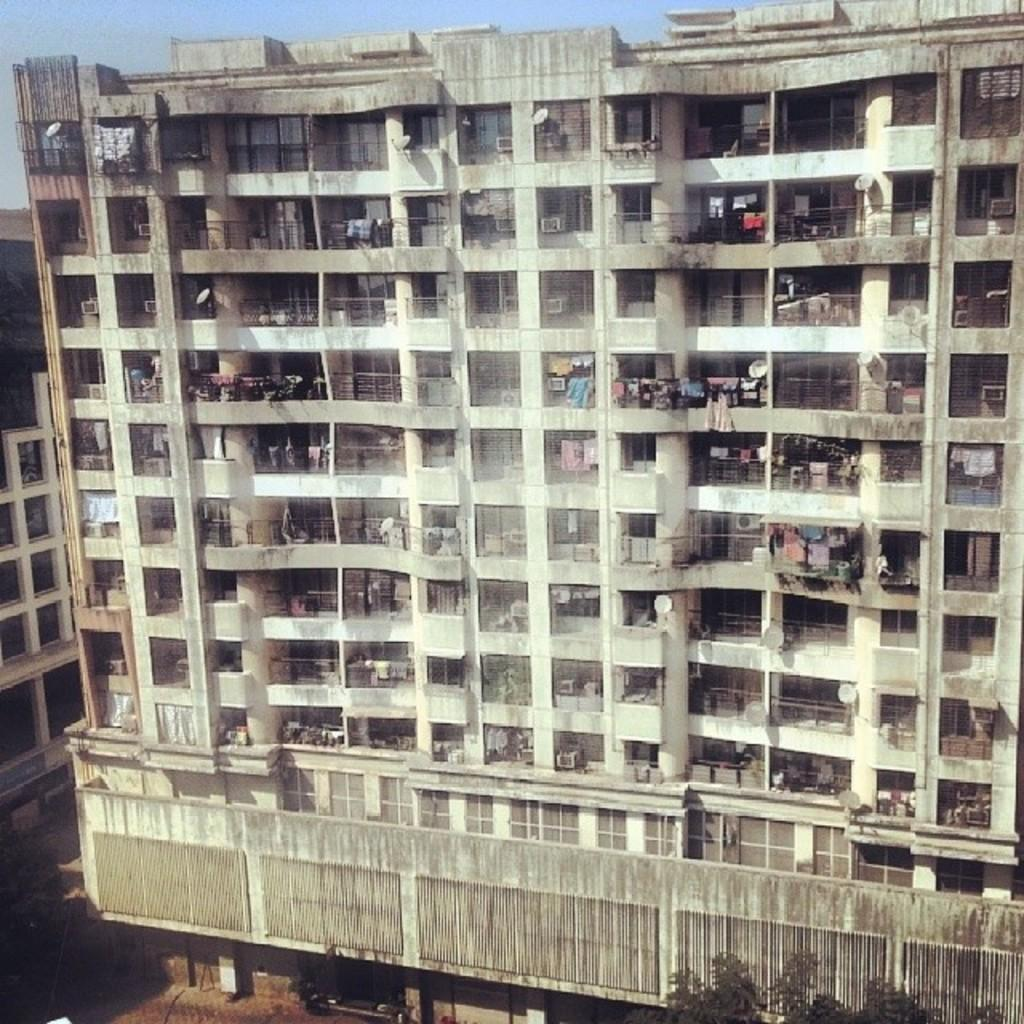What type of structures are present in the image? There are buildings in the image. Can you describe any specific features of the buildings? Yes, there are railings on a building and clothes hanging on another building. What can be seen in the bottom right corner of the image? There are plants in the bottom right corner of the image. What is the color of the sky in the image? The sky is blue in color. How many boys are sorting the clothes on the building in the image? There are no boys present in the image, nor is anyone sorting clothes. 